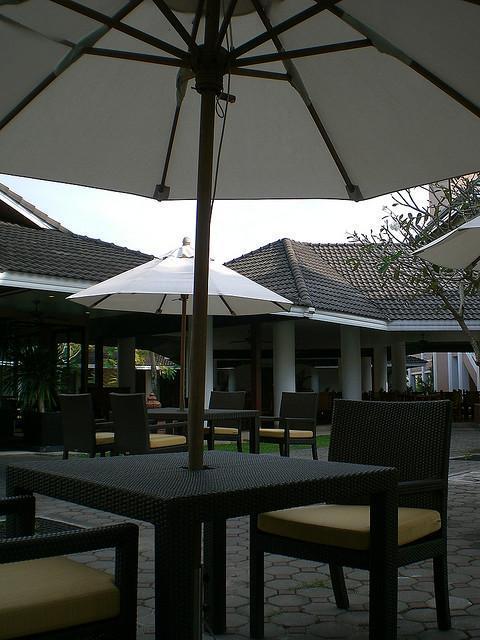How many people are sitting at the table to the left?
Give a very brief answer. 0. How many chairs are there?
Give a very brief answer. 5. How many dining tables are visible?
Give a very brief answer. 1. How many umbrellas are in the picture?
Give a very brief answer. 3. How many white dogs are in the image?
Give a very brief answer. 0. 